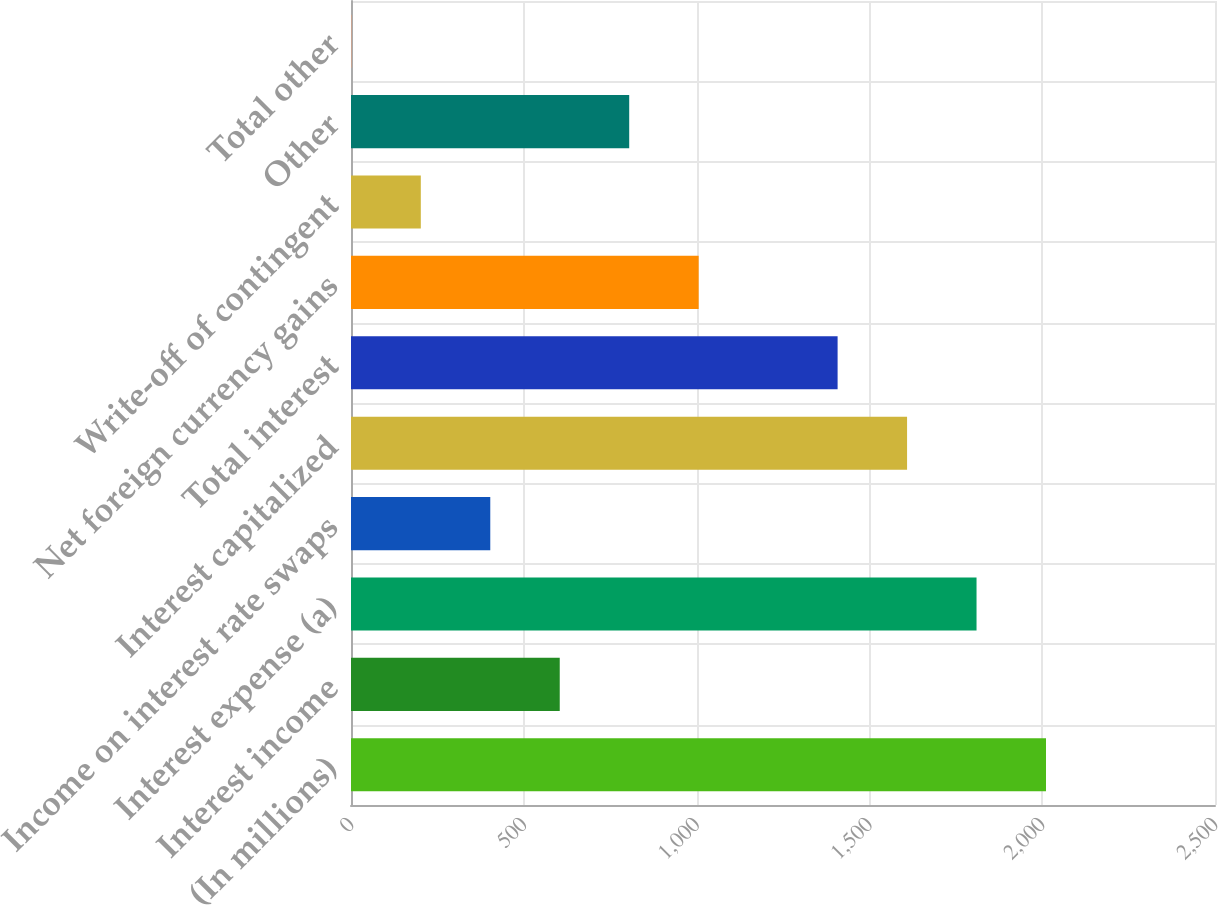<chart> <loc_0><loc_0><loc_500><loc_500><bar_chart><fcel>(In millions)<fcel>Interest income<fcel>Interest expense (a)<fcel>Income on interest rate swaps<fcel>Interest capitalized<fcel>Total interest<fcel>Net foreign currency gains<fcel>Write-off of contingent<fcel>Other<fcel>Total other<nl><fcel>2011<fcel>604<fcel>1810<fcel>403<fcel>1609<fcel>1408<fcel>1006<fcel>202<fcel>805<fcel>1<nl></chart> 